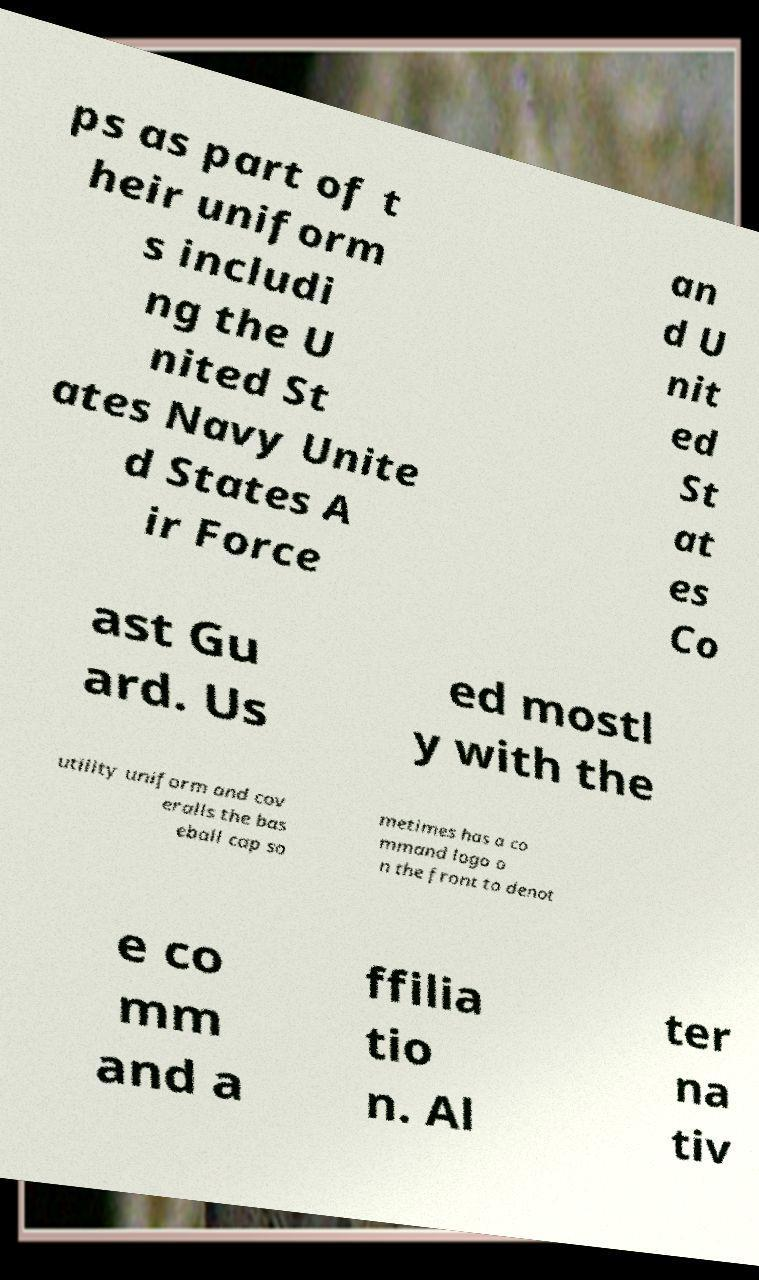Can you read and provide the text displayed in the image?This photo seems to have some interesting text. Can you extract and type it out for me? ps as part of t heir uniform s includi ng the U nited St ates Navy Unite d States A ir Force an d U nit ed St at es Co ast Gu ard. Us ed mostl y with the utility uniform and cov eralls the bas eball cap so metimes has a co mmand logo o n the front to denot e co mm and a ffilia tio n. Al ter na tiv 